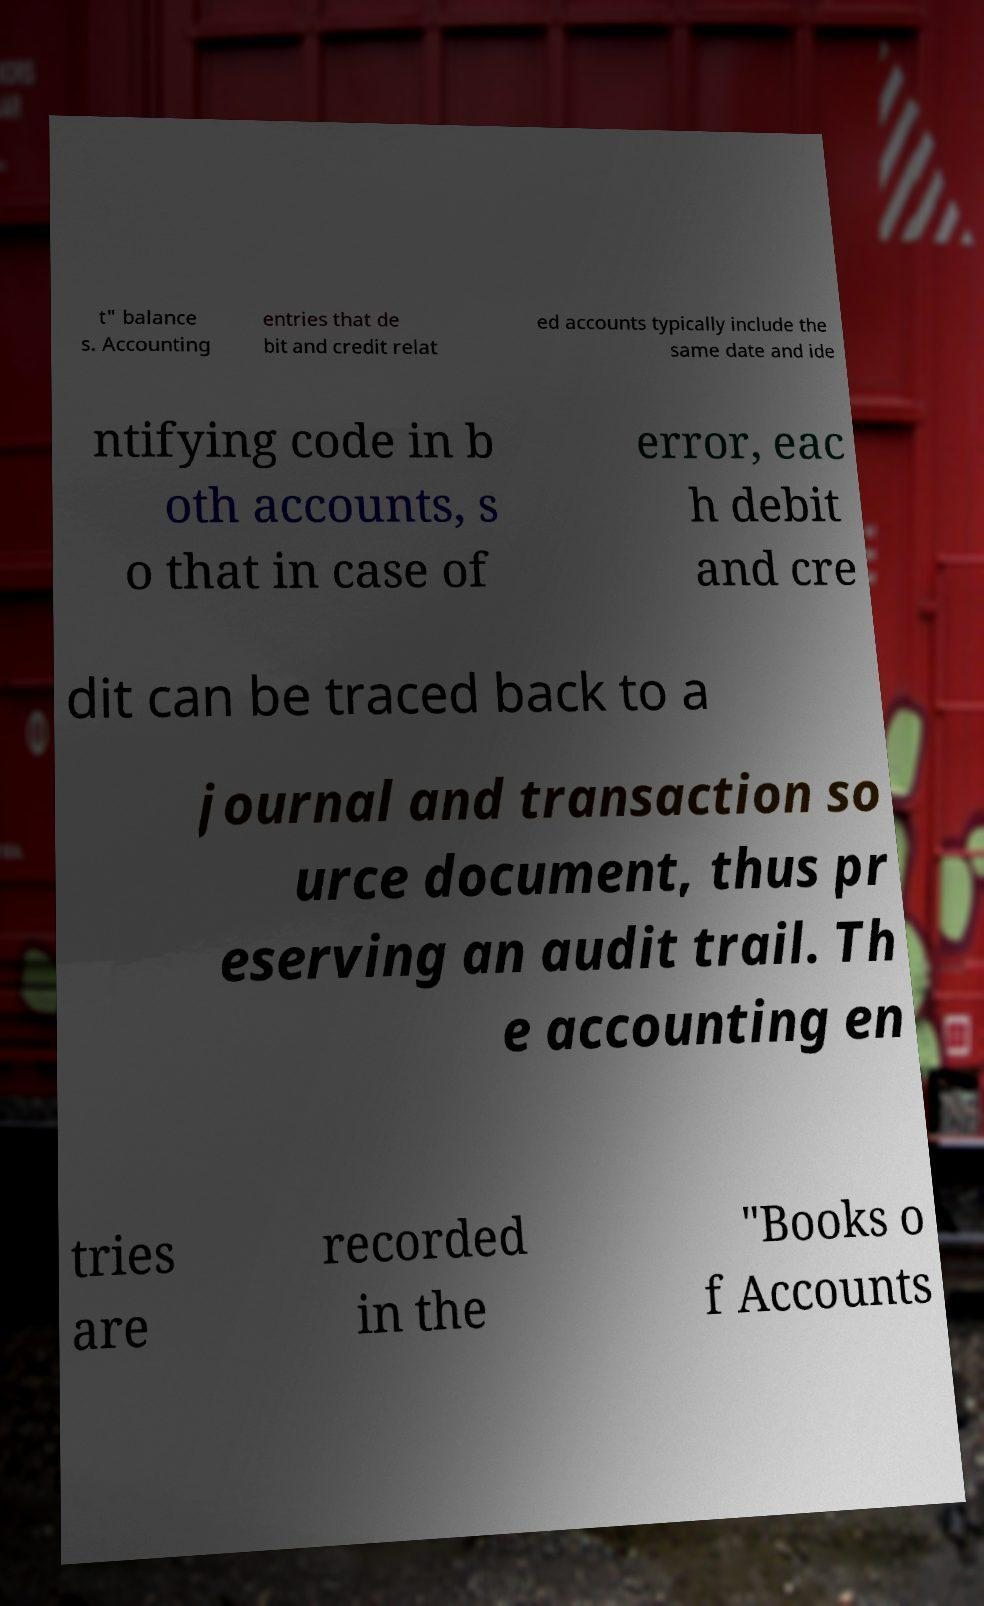Please identify and transcribe the text found in this image. t" balance s. Accounting entries that de bit and credit relat ed accounts typically include the same date and ide ntifying code in b oth accounts, s o that in case of error, eac h debit and cre dit can be traced back to a journal and transaction so urce document, thus pr eserving an audit trail. Th e accounting en tries are recorded in the "Books o f Accounts 